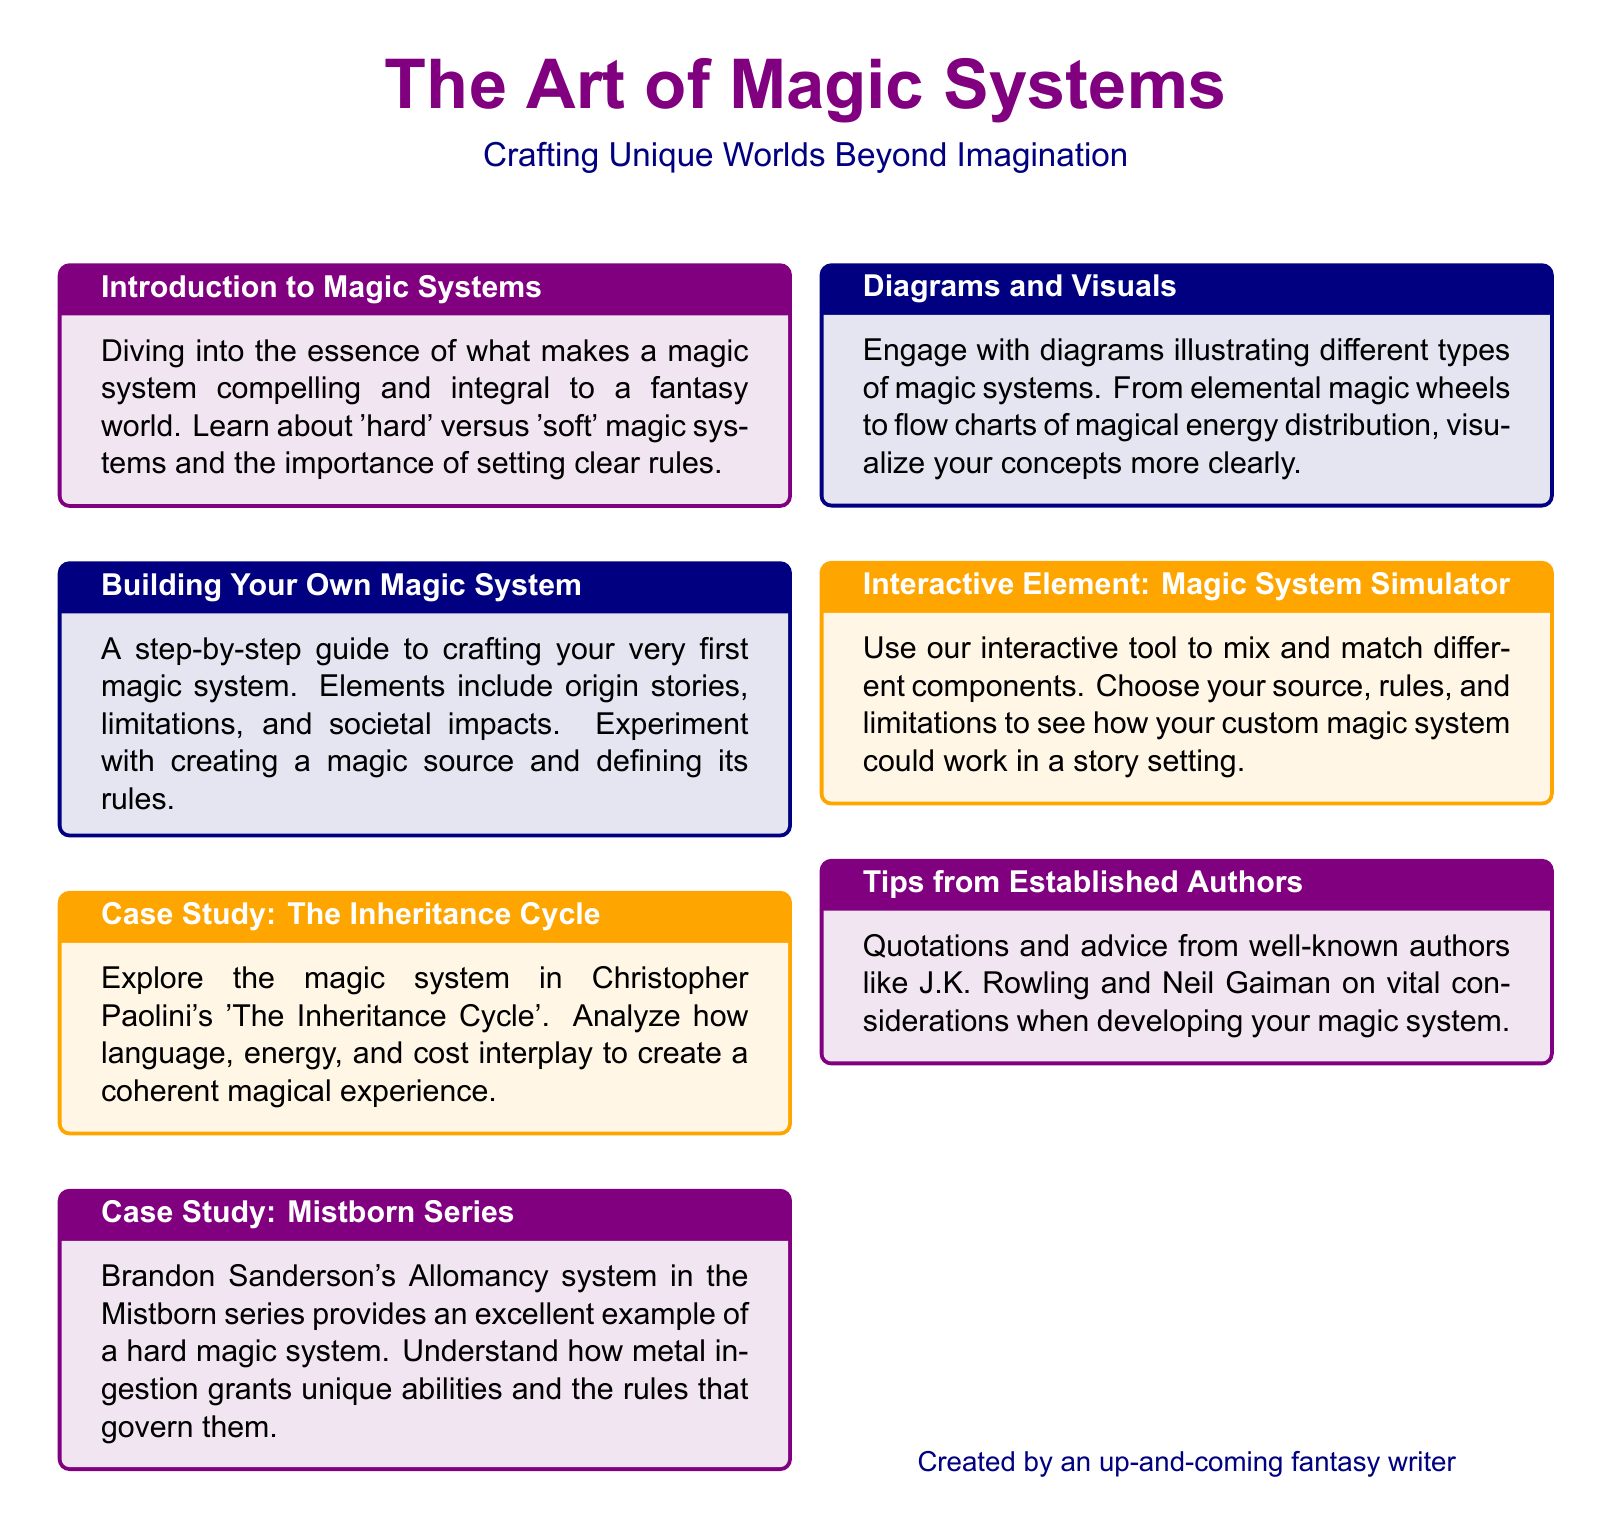What is the title of the document? The title is prominently displayed in a large font at the top of the document.
Answer: The Art of Magic Systems What color is used for the introduction box? The color used for the introduction box is specified in the document's color scheme.
Answer: magicpurple!10 Which famous author is associated with the Mistborn series? The document mentions this author in the context of analyzing a magic system.
Answer: Brandon Sanderson What type of magic system does the Inheritance Cycle feature? The nature of the magic system discussed in the case study is elaborated in the respective section.
Answer: Language-based What is the interactive element provided in the document? This interactive tool allows readers to engage with their own creativity in crafting magic systems.
Answer: Magic System Simulator Which authors' tips are included in the document? The tips come from well-known authors and their quotations are featured as advice.
Answer: J.K. Rowling and Neil Gaiman How many case studies are discussed in the document? The document explicitly outlines the number of case studies that focus on different magic systems.
Answer: Two 